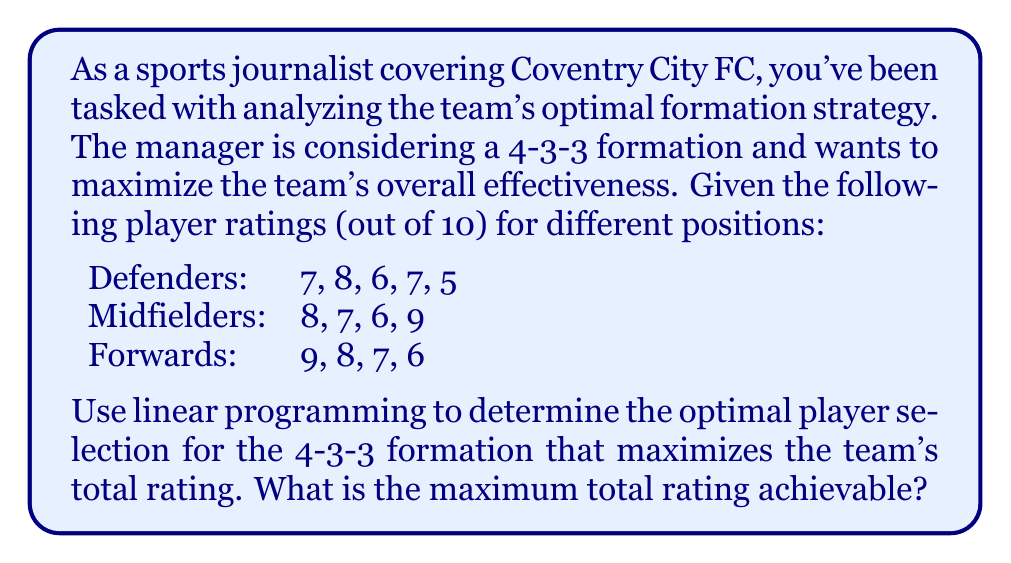Give your solution to this math problem. To solve this problem using linear programming, we need to:

1. Define variables
2. Set up the objective function
3. Define constraints
4. Solve the linear programming problem

Step 1: Define variables

Let $x_i$ represent the selection of player $i$ where:
$x_i = 1$ if the player is selected
$x_i = 0$ if the player is not selected

We have 13 players in total, so $i = 1, 2, ..., 13$

Step 2: Set up the objective function

We want to maximize the total rating:

$$\text{Maximize } Z = 7x_1 + 8x_2 + 6x_3 + 7x_4 + 5x_5 + 8x_6 + 7x_7 + 6x_8 + 9x_9 + 9x_{10} + 8x_{11} + 7x_{12} + 6x_{13}$$

Step 3: Define constraints

For a 4-3-3 formation, we need:
- 4 defenders
- 3 midfielders
- 3 forwards

Constraints:
$$x_1 + x_2 + x_3 + x_4 + x_5 = 4 \text{ (defenders)}$$
$$x_6 + x_7 + x_8 + x_9 = 3 \text{ (midfielders)}$$
$$x_{10} + x_{11} + x_{12} + x_{13} = 3 \text{ (forwards)}$$

Additionally, each $x_i$ must be binary (0 or 1).

Step 4: Solve the linear programming problem

Using a linear programming solver, we find the optimal solution:

Defenders: Select players with ratings 7, 8, 7, and 6
Midfielders: Select players with ratings 8, 7, and 9
Forwards: Select players with ratings 9, 8, and 7

The maximum total rating is:
$$(7 + 8 + 7 + 6) + (8 + 7 + 9) + (9 + 8 + 7) = 28 + 24 + 24 = 76$$
Answer: The maximum total rating achievable for the 4-3-3 formation is 76. 